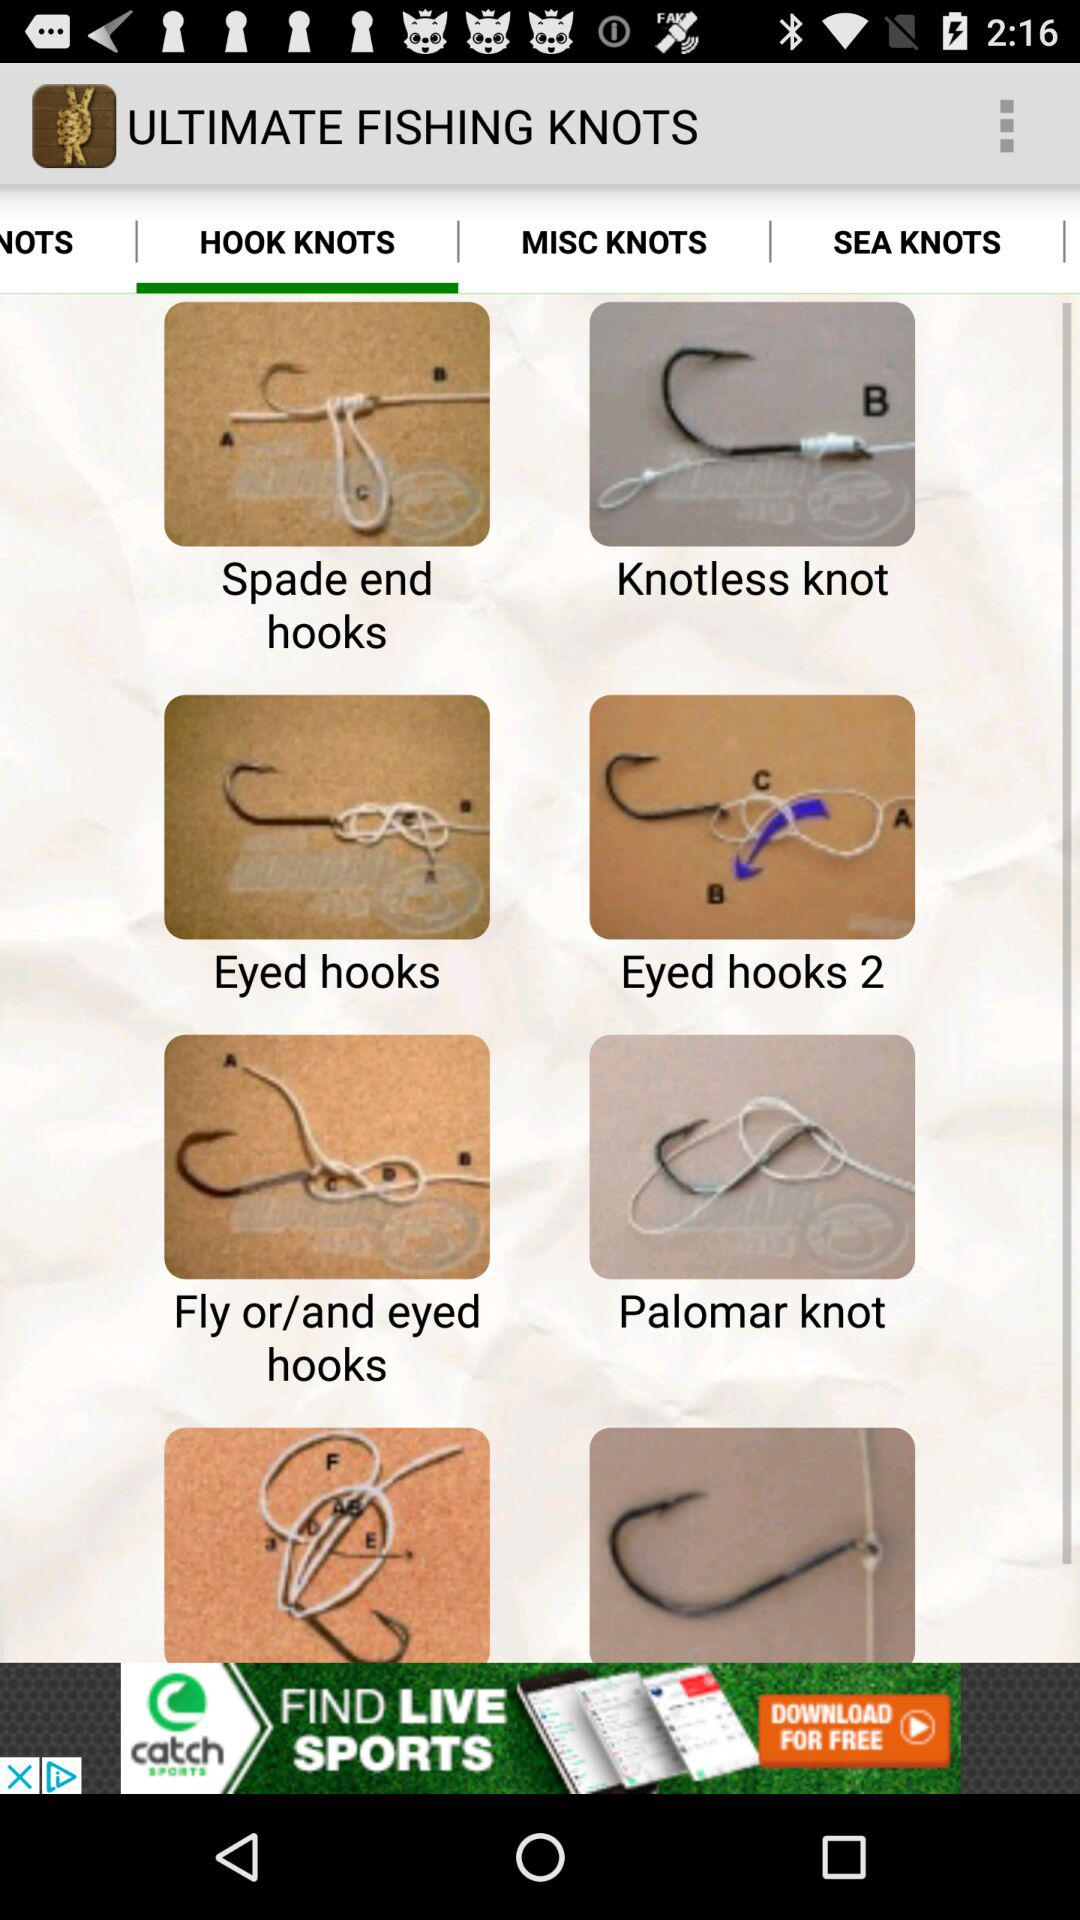Which tab is selected? The selected tab is "HOOK KNOTS". 